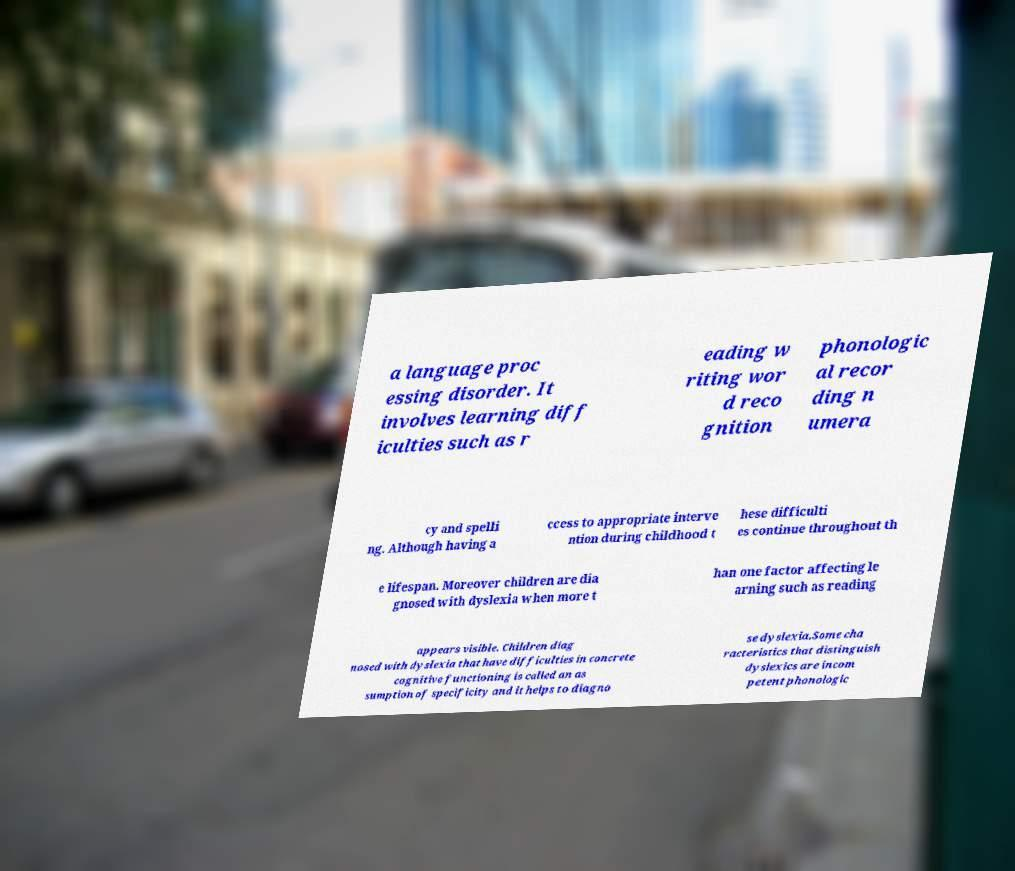For documentation purposes, I need the text within this image transcribed. Could you provide that? a language proc essing disorder. It involves learning diff iculties such as r eading w riting wor d reco gnition phonologic al recor ding n umera cy and spelli ng. Although having a ccess to appropriate interve ntion during childhood t hese difficulti es continue throughout th e lifespan. Moreover children are dia gnosed with dyslexia when more t han one factor affecting le arning such as reading appears visible. Children diag nosed with dyslexia that have difficulties in concrete cognitive functioning is called an as sumption of specificity and it helps to diagno se dyslexia.Some cha racteristics that distinguish dyslexics are incom petent phonologic 